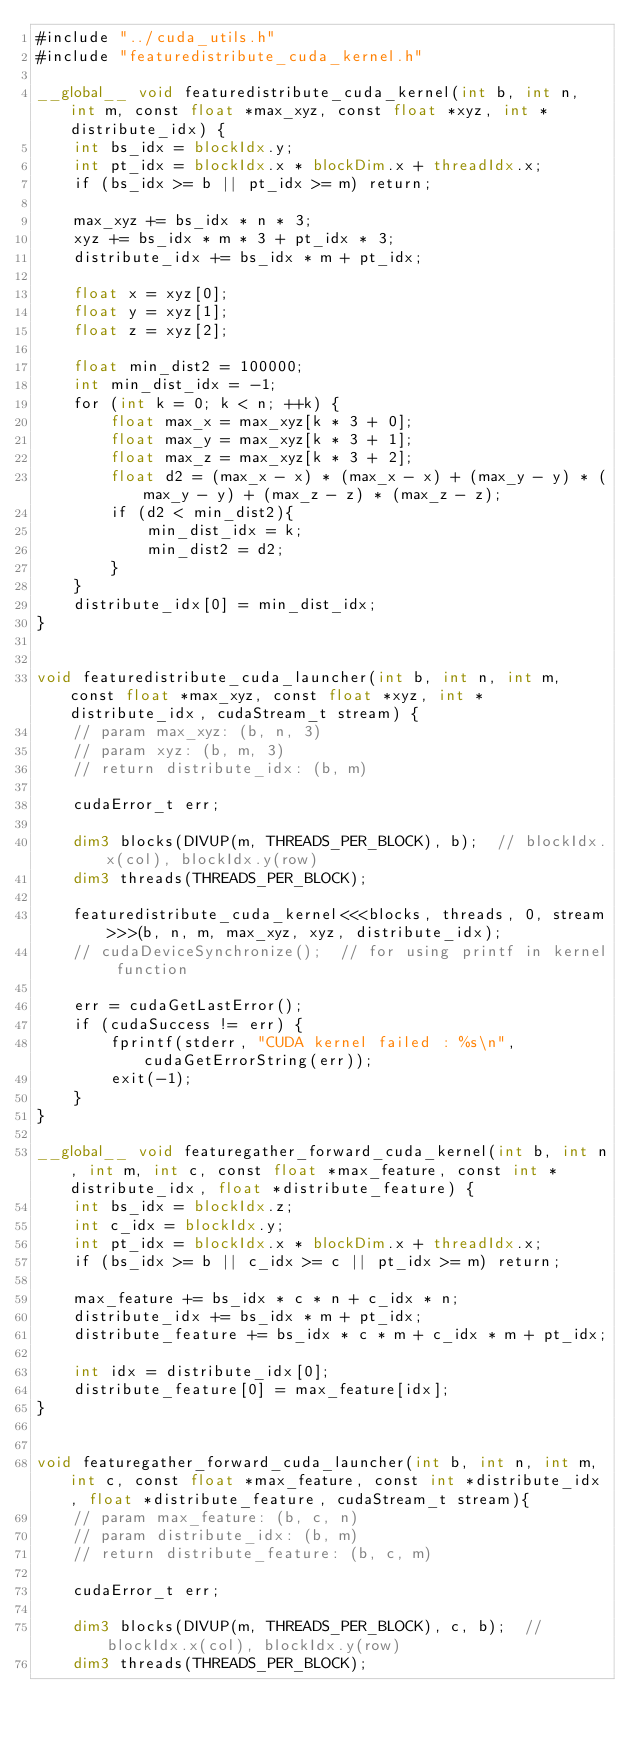<code> <loc_0><loc_0><loc_500><loc_500><_Cuda_>#include "../cuda_utils.h"
#include "featuredistribute_cuda_kernel.h"

__global__ void featuredistribute_cuda_kernel(int b, int n, int m, const float *max_xyz, const float *xyz, int *distribute_idx) {
    int bs_idx = blockIdx.y;
    int pt_idx = blockIdx.x * blockDim.x + threadIdx.x;
    if (bs_idx >= b || pt_idx >= m) return;

    max_xyz += bs_idx * n * 3;
    xyz += bs_idx * m * 3 + pt_idx * 3;
    distribute_idx += bs_idx * m + pt_idx;

    float x = xyz[0];
    float y = xyz[1];
    float z = xyz[2];

    float min_dist2 = 100000;
    int min_dist_idx = -1;
    for (int k = 0; k < n; ++k) {
        float max_x = max_xyz[k * 3 + 0];
        float max_y = max_xyz[k * 3 + 1];
        float max_z = max_xyz[k * 3 + 2];
        float d2 = (max_x - x) * (max_x - x) + (max_y - y) * (max_y - y) + (max_z - z) * (max_z - z);
        if (d2 < min_dist2){
            min_dist_idx = k;
            min_dist2 = d2;
        }
    }
    distribute_idx[0] = min_dist_idx;
}


void featuredistribute_cuda_launcher(int b, int n, int m, const float *max_xyz, const float *xyz, int *distribute_idx, cudaStream_t stream) {
    // param max_xyz: (b, n, 3)
    // param xyz: (b, m, 3)
    // return distribute_idx: (b, m)

    cudaError_t err;

    dim3 blocks(DIVUP(m, THREADS_PER_BLOCK), b);  // blockIdx.x(col), blockIdx.y(row)
    dim3 threads(THREADS_PER_BLOCK);

    featuredistribute_cuda_kernel<<<blocks, threads, 0, stream>>>(b, n, m, max_xyz, xyz, distribute_idx);
    // cudaDeviceSynchronize();  // for using printf in kernel function

    err = cudaGetLastError();
    if (cudaSuccess != err) {
        fprintf(stderr, "CUDA kernel failed : %s\n", cudaGetErrorString(err));
        exit(-1);
    }
}

__global__ void featuregather_forward_cuda_kernel(int b, int n, int m, int c, const float *max_feature, const int *distribute_idx, float *distribute_feature) {
    int bs_idx = blockIdx.z;
    int c_idx = blockIdx.y;
    int pt_idx = blockIdx.x * blockDim.x + threadIdx.x;
    if (bs_idx >= b || c_idx >= c || pt_idx >= m) return;

    max_feature += bs_idx * c * n + c_idx * n;
    distribute_idx += bs_idx * m + pt_idx;
    distribute_feature += bs_idx * c * m + c_idx * m + pt_idx;

    int idx = distribute_idx[0];
    distribute_feature[0] = max_feature[idx];
}


void featuregather_forward_cuda_launcher(int b, int n, int m, int c, const float *max_feature, const int *distribute_idx, float *distribute_feature, cudaStream_t stream){
    // param max_feature: (b, c, n)
    // param distribute_idx: (b, m)
    // return distribute_feature: (b, c, m)

    cudaError_t err;

    dim3 blocks(DIVUP(m, THREADS_PER_BLOCK), c, b);  // blockIdx.x(col), blockIdx.y(row)
    dim3 threads(THREADS_PER_BLOCK);
</code> 